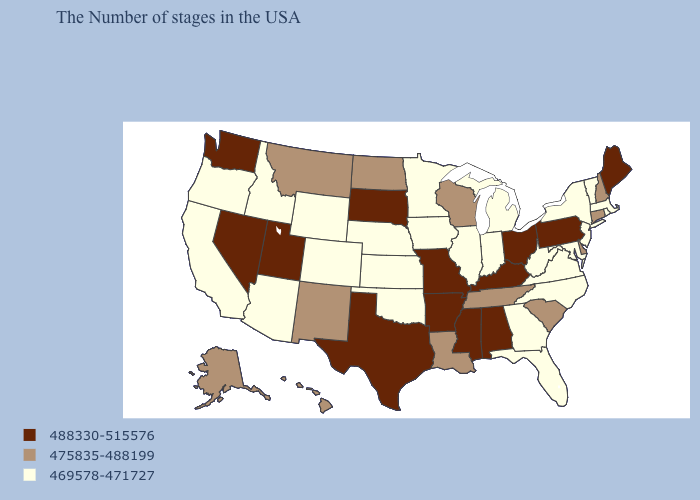Among the states that border Missouri , does Tennessee have the lowest value?
Write a very short answer. No. Which states have the lowest value in the MidWest?
Concise answer only. Michigan, Indiana, Illinois, Minnesota, Iowa, Kansas, Nebraska. What is the value of Missouri?
Short answer required. 488330-515576. What is the value of Nevada?
Write a very short answer. 488330-515576. What is the lowest value in the USA?
Quick response, please. 469578-471727. Which states have the lowest value in the USA?
Give a very brief answer. Massachusetts, Rhode Island, Vermont, New York, New Jersey, Maryland, Virginia, North Carolina, West Virginia, Florida, Georgia, Michigan, Indiana, Illinois, Minnesota, Iowa, Kansas, Nebraska, Oklahoma, Wyoming, Colorado, Arizona, Idaho, California, Oregon. Which states have the lowest value in the West?
Short answer required. Wyoming, Colorado, Arizona, Idaho, California, Oregon. Name the states that have a value in the range 469578-471727?
Quick response, please. Massachusetts, Rhode Island, Vermont, New York, New Jersey, Maryland, Virginia, North Carolina, West Virginia, Florida, Georgia, Michigan, Indiana, Illinois, Minnesota, Iowa, Kansas, Nebraska, Oklahoma, Wyoming, Colorado, Arizona, Idaho, California, Oregon. Name the states that have a value in the range 488330-515576?
Keep it brief. Maine, Pennsylvania, Ohio, Kentucky, Alabama, Mississippi, Missouri, Arkansas, Texas, South Dakota, Utah, Nevada, Washington. What is the highest value in the MidWest ?
Short answer required. 488330-515576. Does the map have missing data?
Give a very brief answer. No. What is the highest value in the Northeast ?
Keep it brief. 488330-515576. Does Delaware have a higher value than Missouri?
Give a very brief answer. No. What is the highest value in the South ?
Short answer required. 488330-515576. 